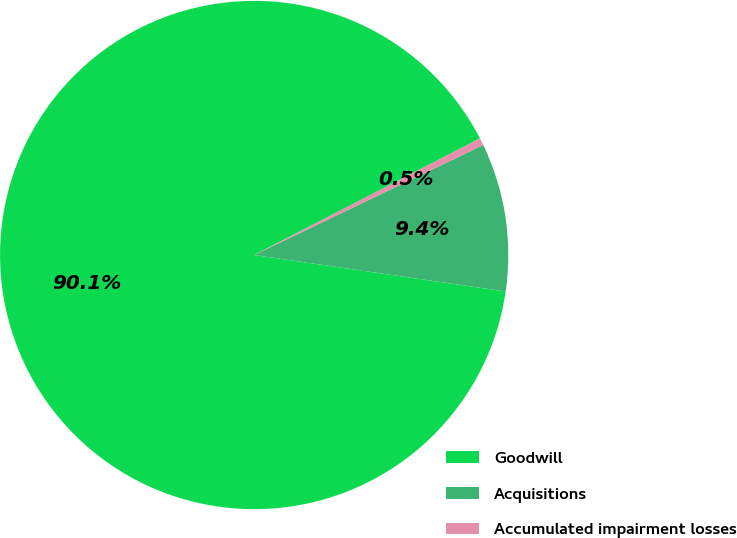<chart> <loc_0><loc_0><loc_500><loc_500><pie_chart><fcel>Goodwill<fcel>Acquisitions<fcel>Accumulated impairment losses<nl><fcel>90.12%<fcel>9.42%<fcel>0.46%<nl></chart> 